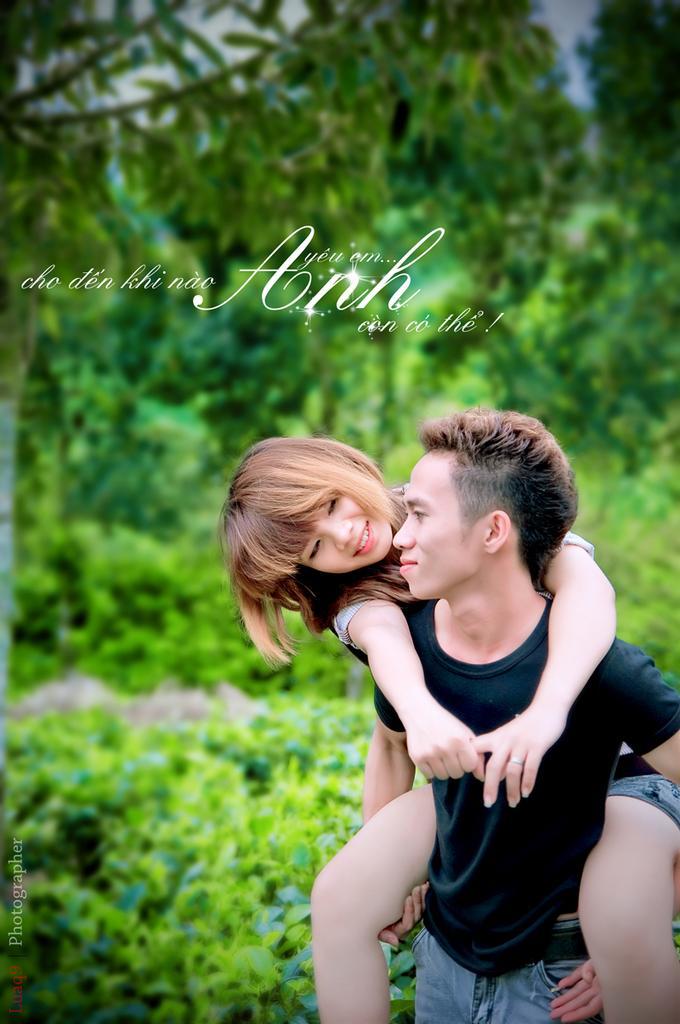Can you describe this image briefly? In this image it looks like a poster in which there is a man who is carrying the girl on his shoulders. In the background there are trees. 